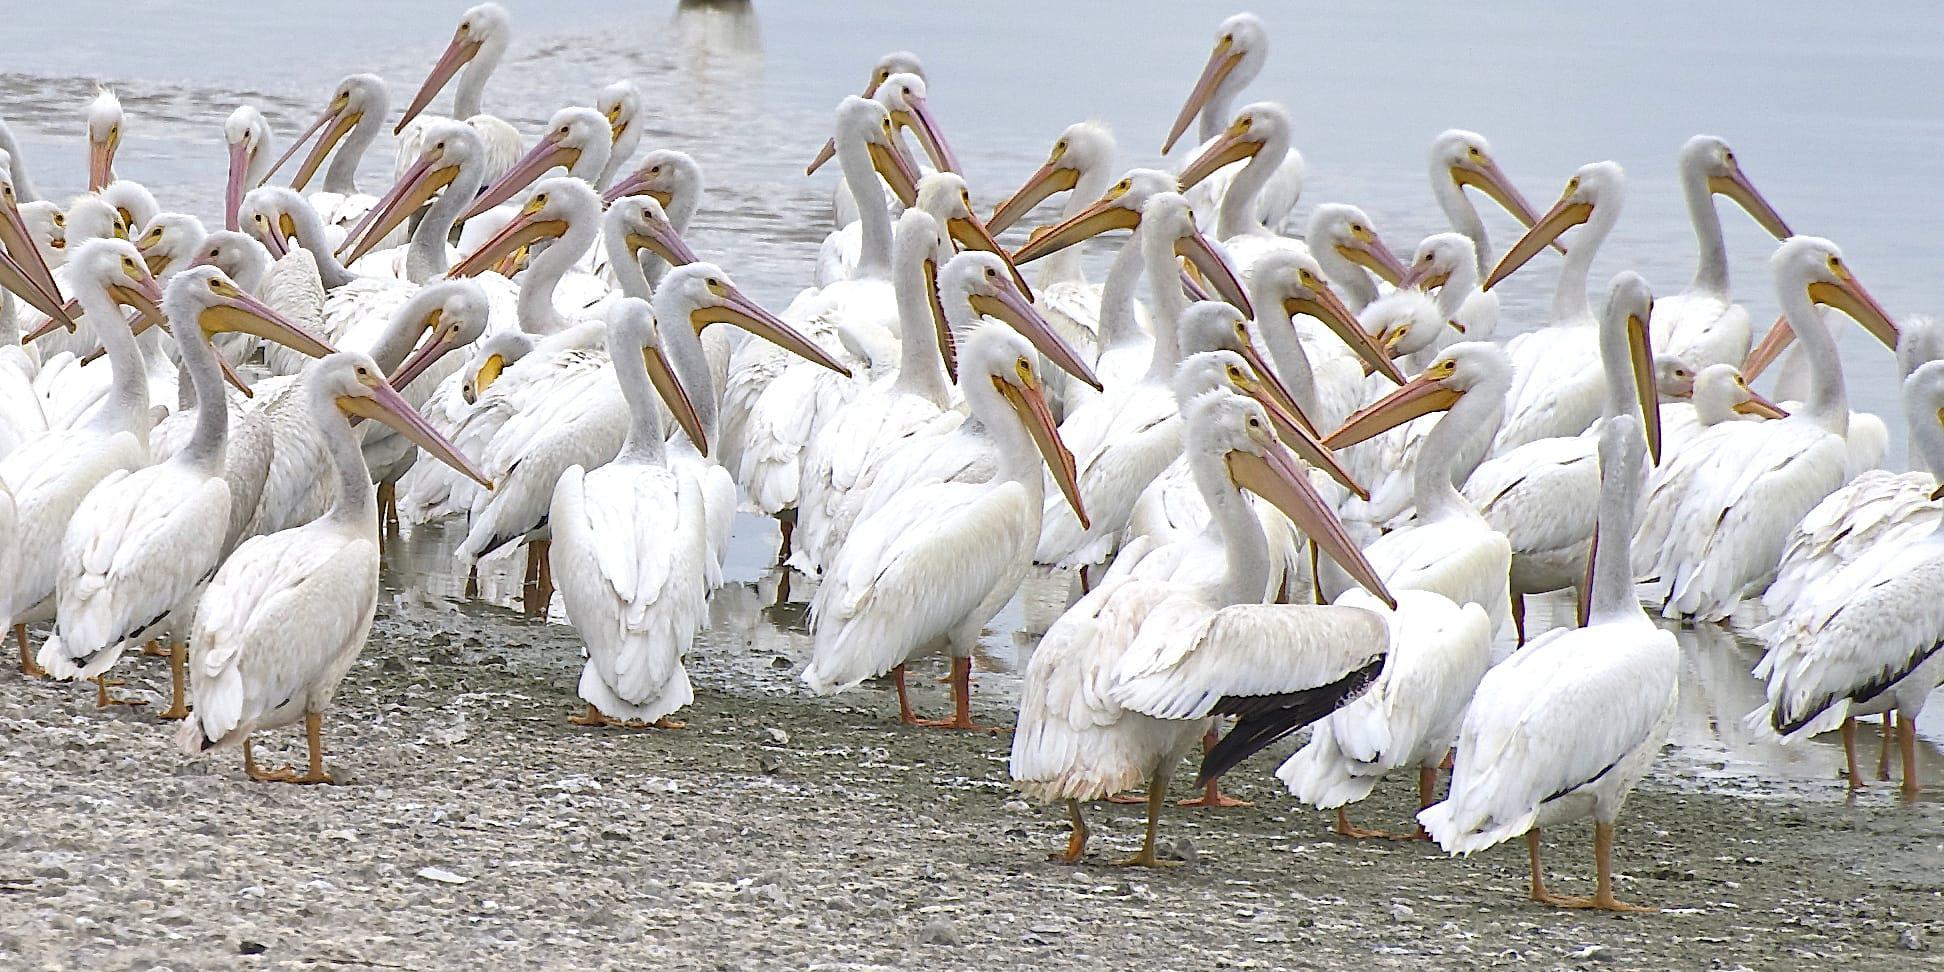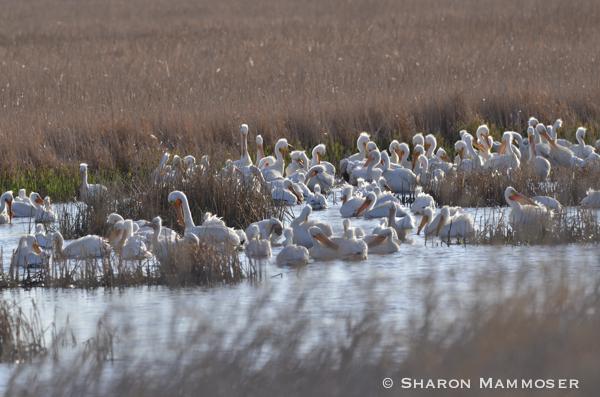The first image is the image on the left, the second image is the image on the right. For the images shown, is this caption "There are exactly three pelicans in one of the images" true? Answer yes or no. No. The first image is the image on the left, the second image is the image on the right. Assess this claim about the two images: "There are 3 storks on the left image". Correct or not? Answer yes or no. No. 